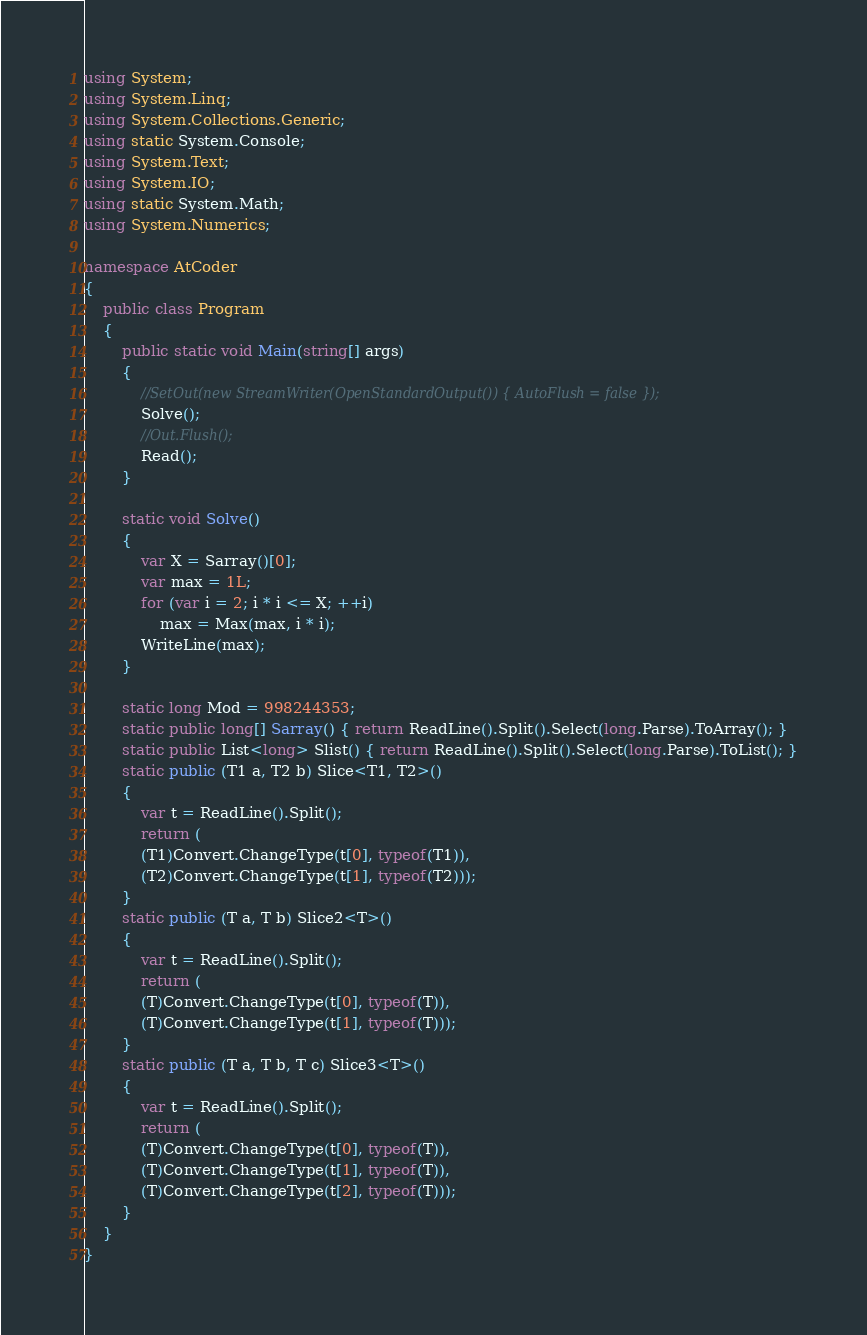<code> <loc_0><loc_0><loc_500><loc_500><_C#_>using System;
using System.Linq;
using System.Collections.Generic;
using static System.Console;
using System.Text;
using System.IO;
using static System.Math;
using System.Numerics;

namespace AtCoder
{
    public class Program
    {
        public static void Main(string[] args)
        {
            //SetOut(new StreamWriter(OpenStandardOutput()) { AutoFlush = false });
            Solve();
            //Out.Flush();
            Read();
        }

        static void Solve()
        {
            var X = Sarray()[0];
            var max = 1L;
            for (var i = 2; i * i <= X; ++i)
                max = Max(max, i * i);
            WriteLine(max);
        }

        static long Mod = 998244353;
        static public long[] Sarray() { return ReadLine().Split().Select(long.Parse).ToArray(); }
        static public List<long> Slist() { return ReadLine().Split().Select(long.Parse).ToList(); }
        static public (T1 a, T2 b) Slice<T1, T2>()
        {
            var t = ReadLine().Split();
            return (
            (T1)Convert.ChangeType(t[0], typeof(T1)),
            (T2)Convert.ChangeType(t[1], typeof(T2)));
        }
        static public (T a, T b) Slice2<T>()
        {
            var t = ReadLine().Split();
            return (
            (T)Convert.ChangeType(t[0], typeof(T)),
            (T)Convert.ChangeType(t[1], typeof(T)));
        }
        static public (T a, T b, T c) Slice3<T>()
        {
            var t = ReadLine().Split();
            return (
            (T)Convert.ChangeType(t[0], typeof(T)),
            (T)Convert.ChangeType(t[1], typeof(T)),
            (T)Convert.ChangeType(t[2], typeof(T)));
        }
    }
}</code> 